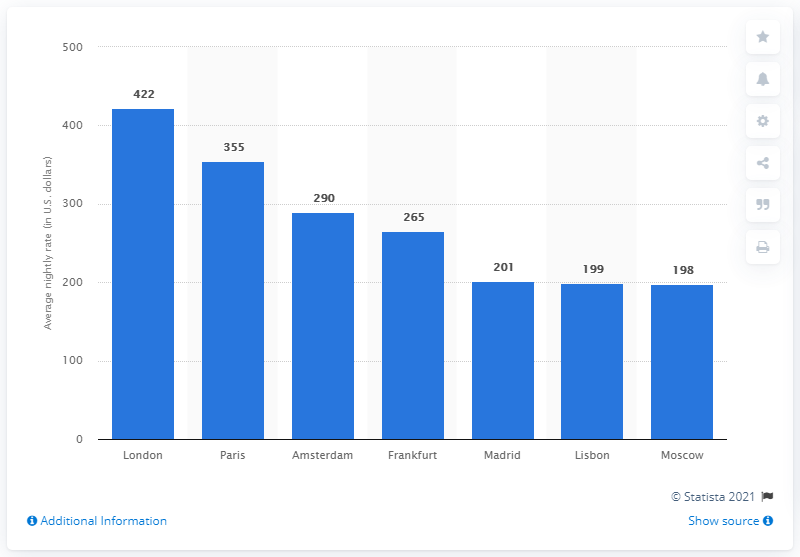Indicate a few pertinent items in this graphic. The average nightly rate in Amsterdam was 290 dollars in USD. 